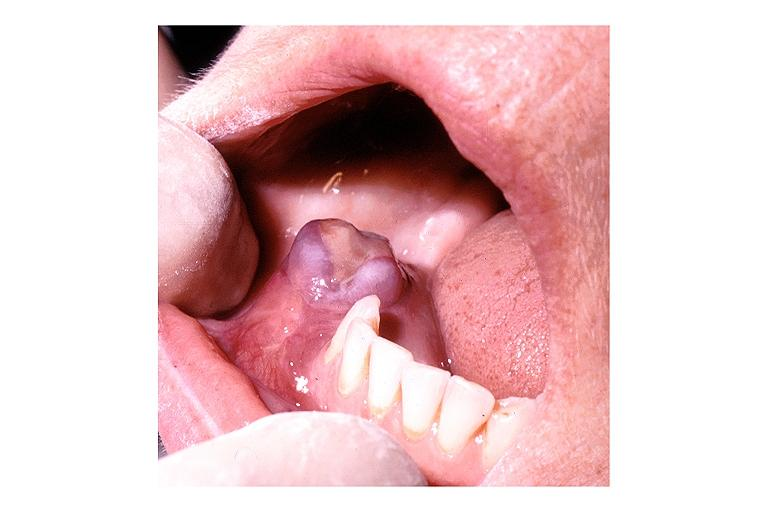where is this?
Answer the question using a single word or phrase. Oral 